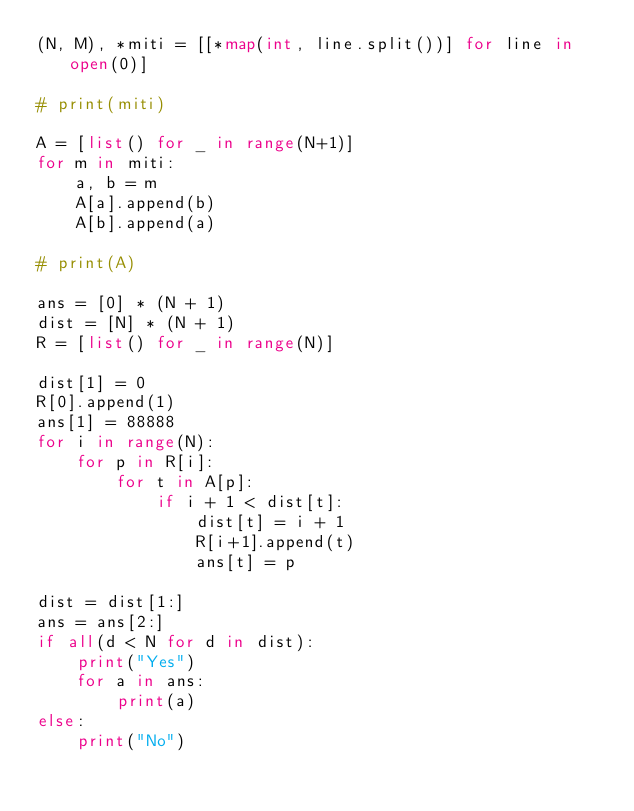<code> <loc_0><loc_0><loc_500><loc_500><_Python_>(N, M), *miti = [[*map(int, line.split())] for line in open(0)]

# print(miti)

A = [list() for _ in range(N+1)]
for m in miti:
    a, b = m
    A[a].append(b)
    A[b].append(a)

# print(A)

ans = [0] * (N + 1)
dist = [N] * (N + 1)
R = [list() for _ in range(N)]

dist[1] = 0
R[0].append(1)
ans[1] = 88888
for i in range(N):
    for p in R[i]:
        for t in A[p]:
            if i + 1 < dist[t]:
                dist[t] = i + 1
                R[i+1].append(t)
                ans[t] = p

dist = dist[1:]
ans = ans[2:]
if all(d < N for d in dist):
    print("Yes")
    for a in ans:
        print(a)
else:
    print("No")</code> 